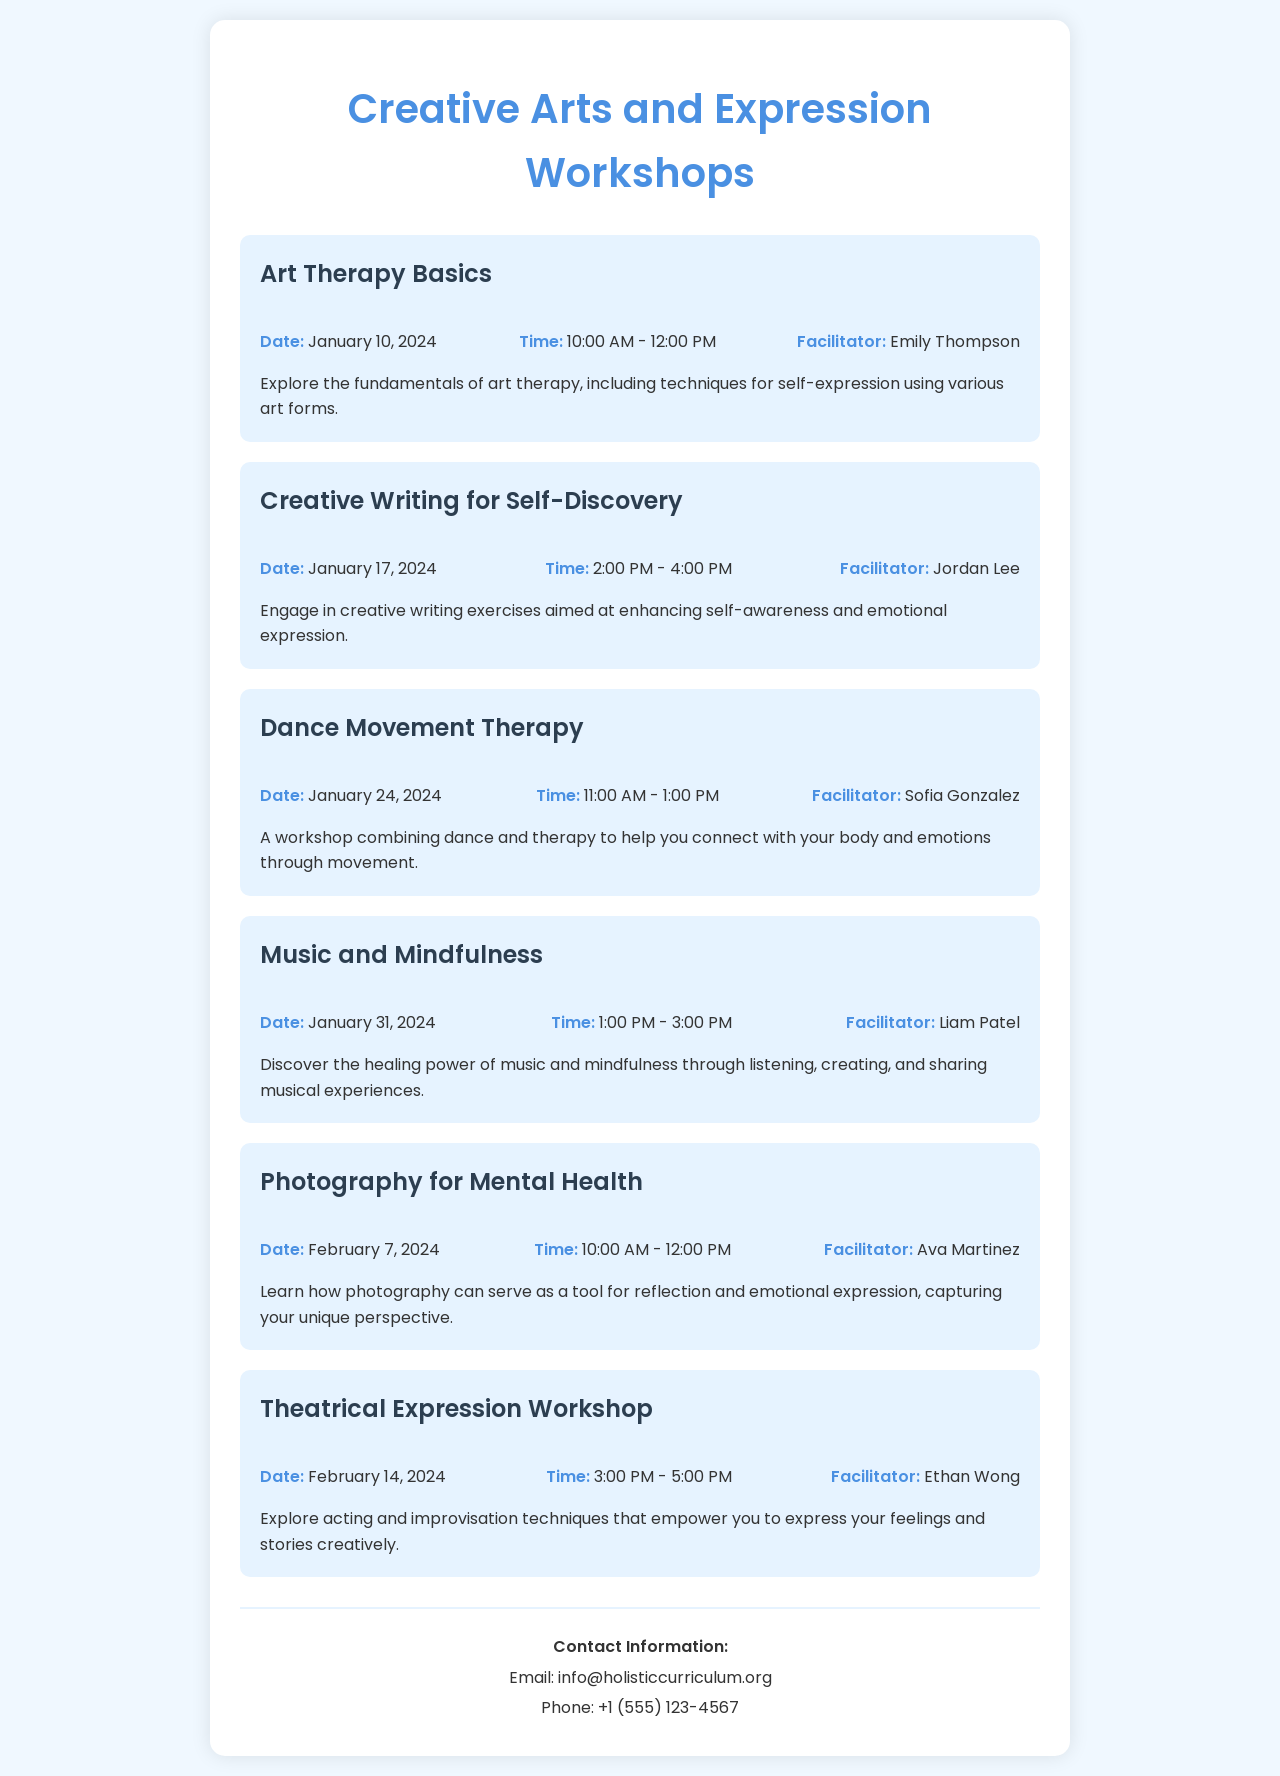What is the title of the first workshop? The first workshop is titled "Art Therapy Basics."
Answer: Art Therapy Basics Who is the facilitator for the "Creative Writing for Self-Discovery" workshop? The facilitator for this workshop is Jordan Lee.
Answer: Jordan Lee When does the "Dance Movement Therapy" workshop take place? The workshop occurs on January 24, 2024.
Answer: January 24, 2024 What time is the "Music and Mindfulness" workshop scheduled for? The workshop is scheduled from 1:00 PM to 3:00 PM.
Answer: 1:00 PM - 3:00 PM How many workshops are scheduled in February? There are two workshops scheduled in February.
Answer: Two What is the focus of the "Photography for Mental Health" workshop? The focus is on using photography as a tool for reflection and emotional expression.
Answer: Reflection and emotional expression Which workshop is set for Valentine's Day? The workshop scheduled for Valentine's Day is "Theatrical Expression Workshop."
Answer: Theatrical Expression Workshop What is the contact email provided in the document? The contact email is info@holisticcurriculum.org.
Answer: info@holisticcurriculum.org 